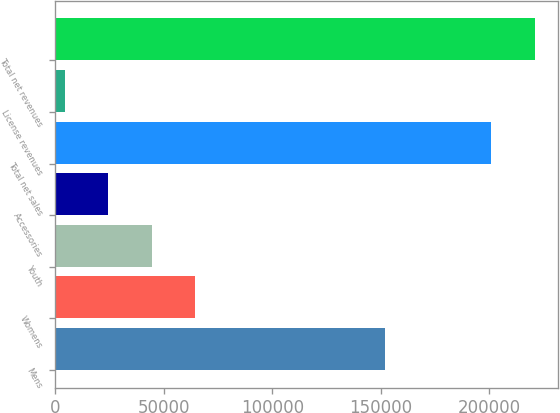<chart> <loc_0><loc_0><loc_500><loc_500><bar_chart><fcel>Mens<fcel>Womens<fcel>Youth<fcel>Accessories<fcel>Total net sales<fcel>License revenues<fcel>Total net revenues<nl><fcel>151962<fcel>64569.2<fcel>44481.8<fcel>24394.4<fcel>200874<fcel>4307<fcel>220961<nl></chart> 